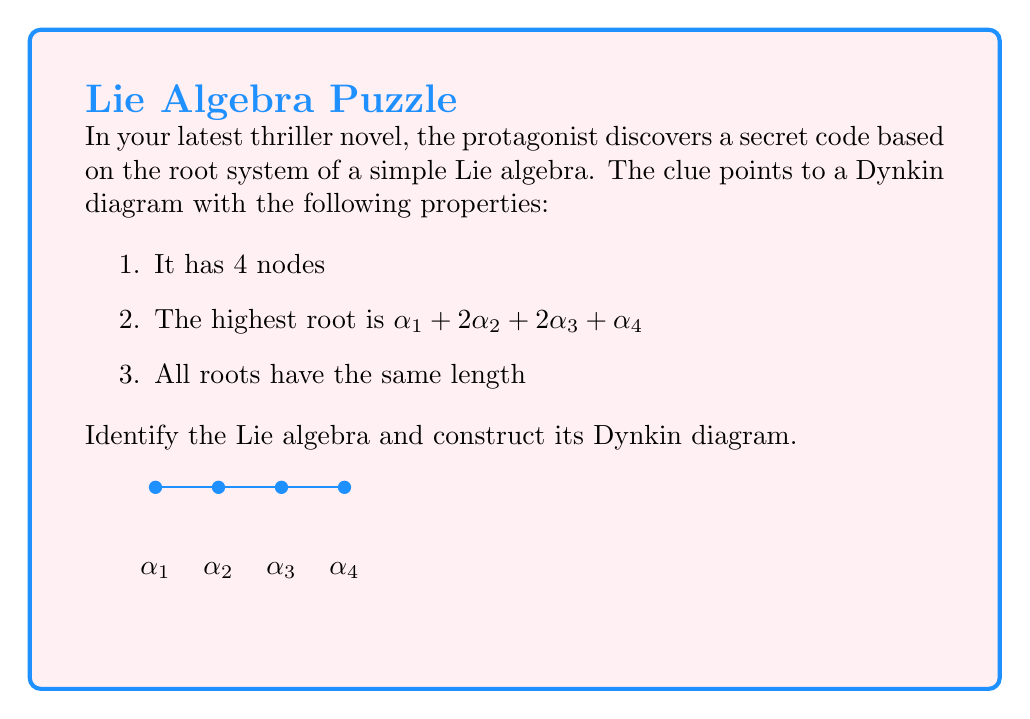Solve this math problem. Let's approach this step-by-step:

1) The number of nodes in a Dynkin diagram corresponds to the rank of the Lie algebra. Here, we have 4 nodes, so we're dealing with a rank 4 Lie algebra.

2) The fact that all roots have the same length indicates that this is a simply-laced Lie algebra. The simply-laced Lie algebras are $A_n$, $D_n$, and $E_6$, $E_7$, $E_8$.

3) Given the rank is 4, we can narrow it down to either $A_4$ or $D_4$.

4) The key to distinguishing between these is the highest root. For $A_n$, the highest root is always of the form:

   $$\alpha_1 + \alpha_2 + ... + \alpha_n$$

5) For $D_n$, the highest root is:

   $$\alpha_1 + 2\alpha_2 + ... + 2\alpha_{n-2} + \alpha_{n-1} + \alpha_n$$

6) The given highest root $\alpha_1 + 2\alpha_2 + 2\alpha_3 + \alpha_4$ matches the form for $D_4$.

7) Therefore, we can conclude that this is the Lie algebra $D_4$, also known as $so(8)$.

8) The Dynkin diagram for $D_4$ is characterized by a central node connected to three outer nodes. It's often called the "tri-valent" diagram due to its three-fold symmetry.
Answer: $D_4$ (or $so(8)$)

[asy]
unitsize(1cm);
dot((0,0)); dot((1,1)); dot((1,0)); dot((1,-1));
draw((0,0)--(1,1));
draw((0,0)--(1,0));
draw((0,0)--(1,-1));
label("$\alpha_2$", (-0.3,0));
label("$\alpha_1$", (1.3,1));
label("$\alpha_3$", (1.3,0));
label("$\alpha_4$", (1.3,-1));
[/asy] 